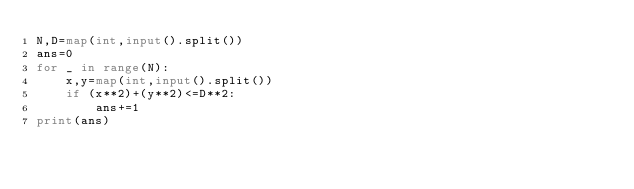<code> <loc_0><loc_0><loc_500><loc_500><_Python_>N,D=map(int,input().split())
ans=0
for _ in range(N):
    x,y=map(int,input().split())
    if (x**2)+(y**2)<=D**2:
        ans+=1
print(ans)
</code> 